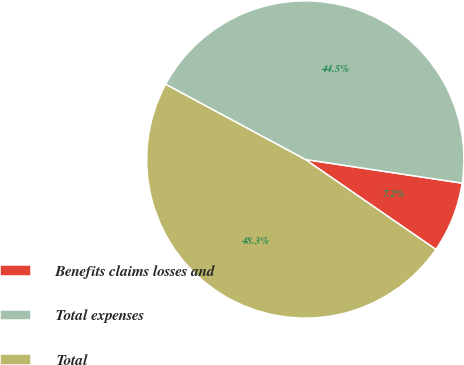Convert chart to OTSL. <chart><loc_0><loc_0><loc_500><loc_500><pie_chart><fcel>Benefits claims losses and<fcel>Total expenses<fcel>Total<nl><fcel>7.22%<fcel>44.52%<fcel>48.26%<nl></chart> 